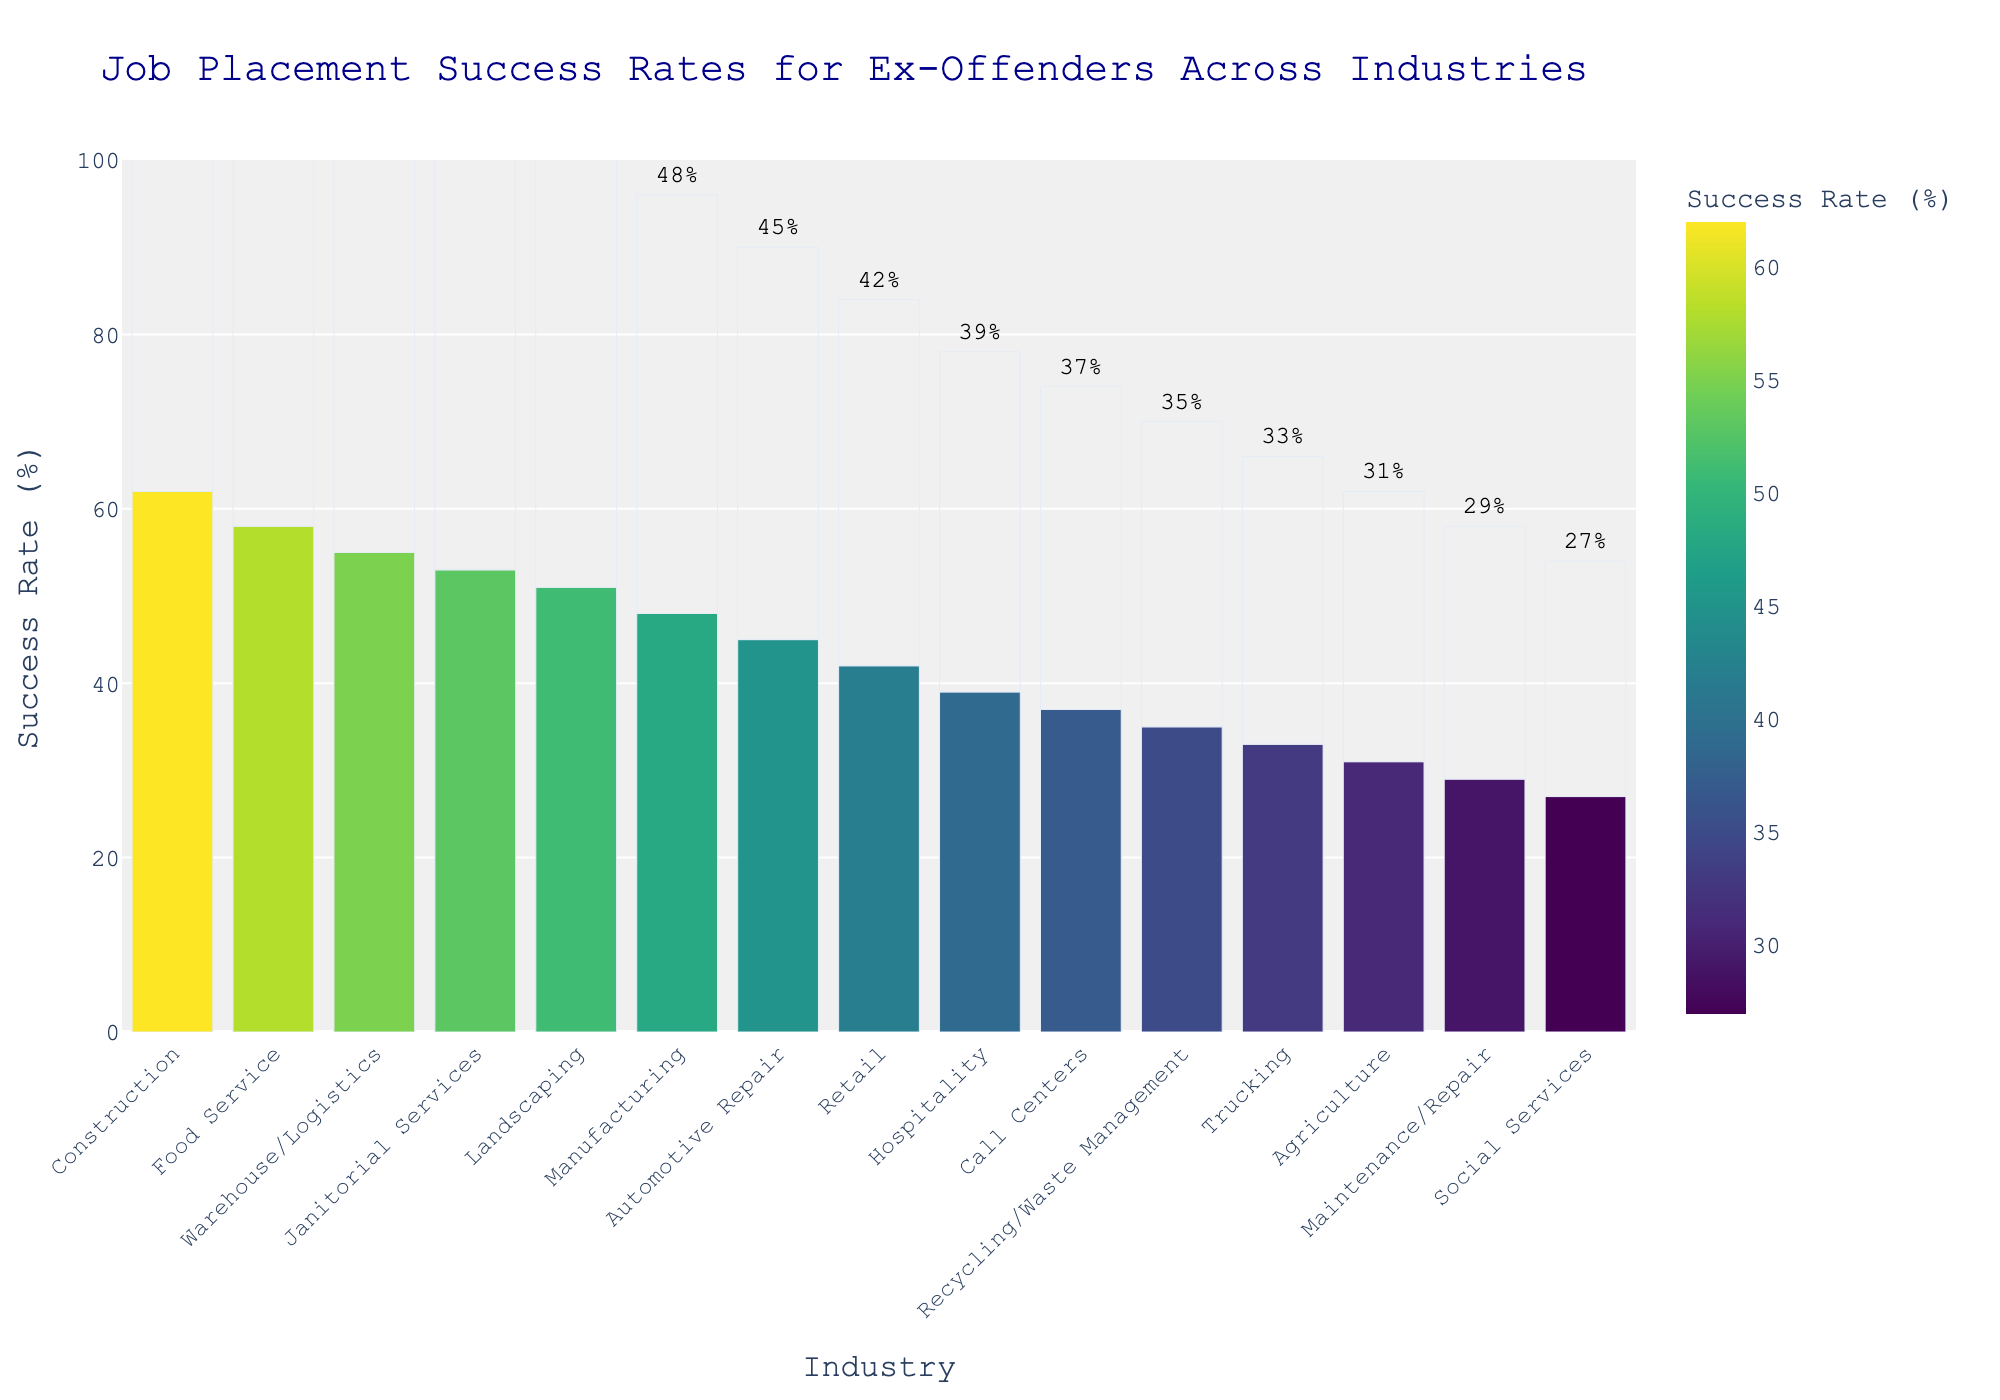What is the industry with the highest job placement success rate for ex-offenders? The bar chart shows different industries and their corresponding job placement success rates for ex-offenders. The highest bar represents the industry with the highest success rate. In this case, the Construction industry has the highest success rate at 62%.
Answer: Construction Which industries have a placement rate higher than 50%? By observing the bars in the chart, we can identify the industries with placement rates higher than 50% by looking for bars with heights greater than the midpoint (50%). These industries are Construction, Food Service, Warehouse/Logistics, Janitorial Services, and Landscaping.
Answer: Construction, Food Service, Warehouse/Logistics, Janitorial Services, Landscaping How much higher is the success rate in Construction compared to Agriculture? The success rate for Construction is 62%, and for Agriculture, it is 31%. To find the difference, subtract the Agriculture rate from the Construction rate: 62% - 31% = 31%.
Answer: 31% What's the average job placement success rate across all listed industries? To find the average, we sum the placement rates of all industries and divide by the number of industries. The sum is: 62 + 58 + 55 + 53 + 51 + 48 + 45 + 42 + 39 + 37 + 35 + 33 + 31 + 29 + 27 = 645. There are 15 industries, so the average rate is 645 / 15 = 43%.
Answer: 43% Which industry has a placement rate closest to the median value? To find the median, we first list the placement rates in ascending order: 27, 29, 31, 33, 35, 37, 39, 42, 45, 48, 51, 53, 55, 58, 62. The median value is the one in the middle, which is 42%. The Retail industry has this placement rate.
Answer: Retail Identify the third highest industry in terms of job placement success rate? The chart sorted in descending order shows the third highest bar corresponding to the Warehouse/Logistics industry with a 55% success rate.
Answer: Warehouse/Logistics What is the combined placement rate for the top three industries? The top three industries and their rates are Construction (62%), Food Service (58%), and Warehouse/Logistics (55%). Adding these rates together: 62% + 58% + 55% = 175%.
Answer: 175% Between Janitorial Services and Hospitality, which industry has a higher placement rate and by how much? The placement rate for Janitorial Services is 53%, while for Hospitality, it is 39%. The difference is 53% - 39% = 14%. Thus, Janitorial Services has a higher placement rate by 14%.
Answer: Janitorial Services by 14% What are the bottom three industries in terms of placement success rates? Referring to the bar chart, the three shortest bars represent the industries with the lowest placement rates. These are Maintenance/Repair (29%), Social Services (27%), and Agriculture (31%). Since Maintenance/Repair and Social Services have the lowest rates, the correct bottom three are Social Services, Maintenance/Repair, and Agriculture.
Answer: Social Services, Maintenance/Repair, Agriculture Which industry has a placement rate that is half the rate of the Construction industry? The Construction industry has a 62% placement rate. Half of 62% is 31%. The Agriculture industry has a placement rate of 31%, which is exactly half of the Construction rate.
Answer: Agriculture 